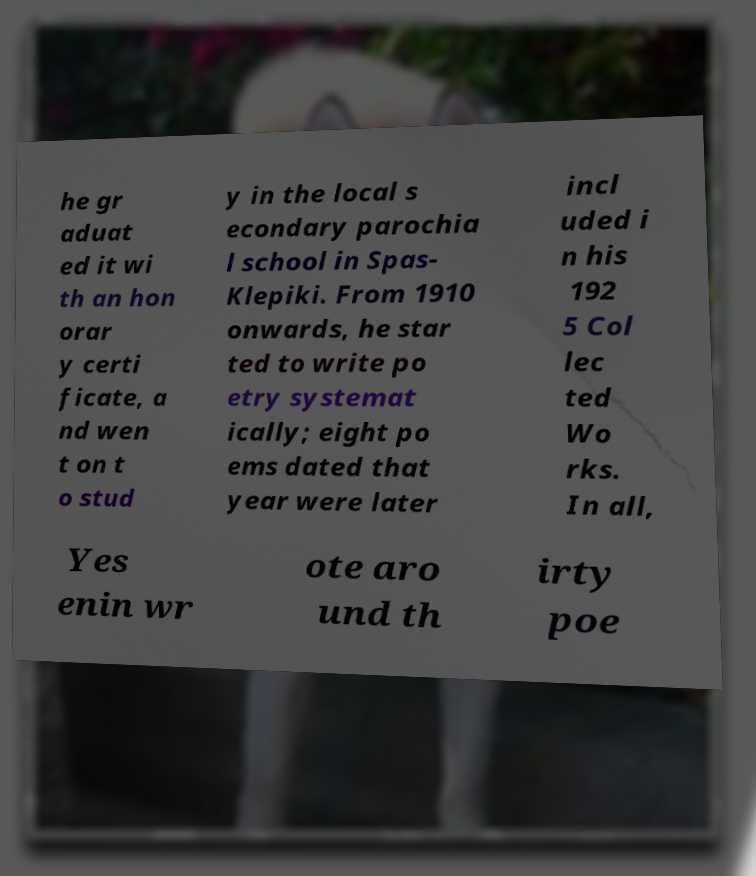What messages or text are displayed in this image? I need them in a readable, typed format. he gr aduat ed it wi th an hon orar y certi ficate, a nd wen t on t o stud y in the local s econdary parochia l school in Spas- Klepiki. From 1910 onwards, he star ted to write po etry systemat ically; eight po ems dated that year were later incl uded i n his 192 5 Col lec ted Wo rks. In all, Yes enin wr ote aro und th irty poe 